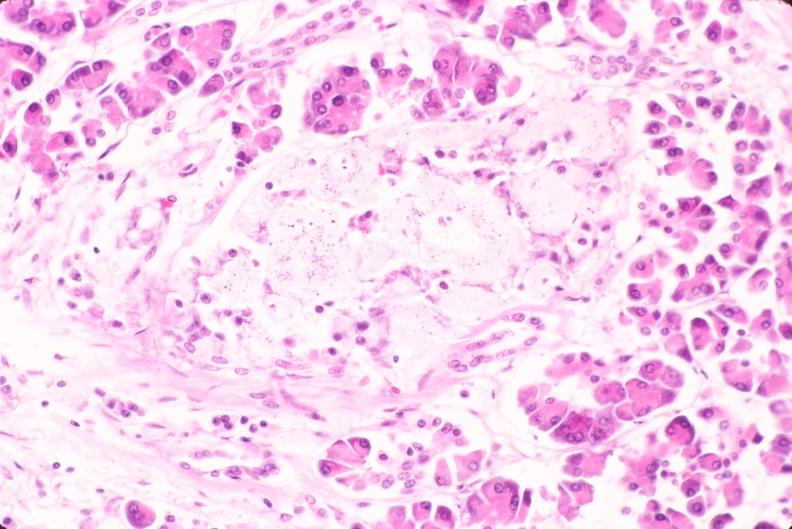s vasculature present?
Answer the question using a single word or phrase. No 